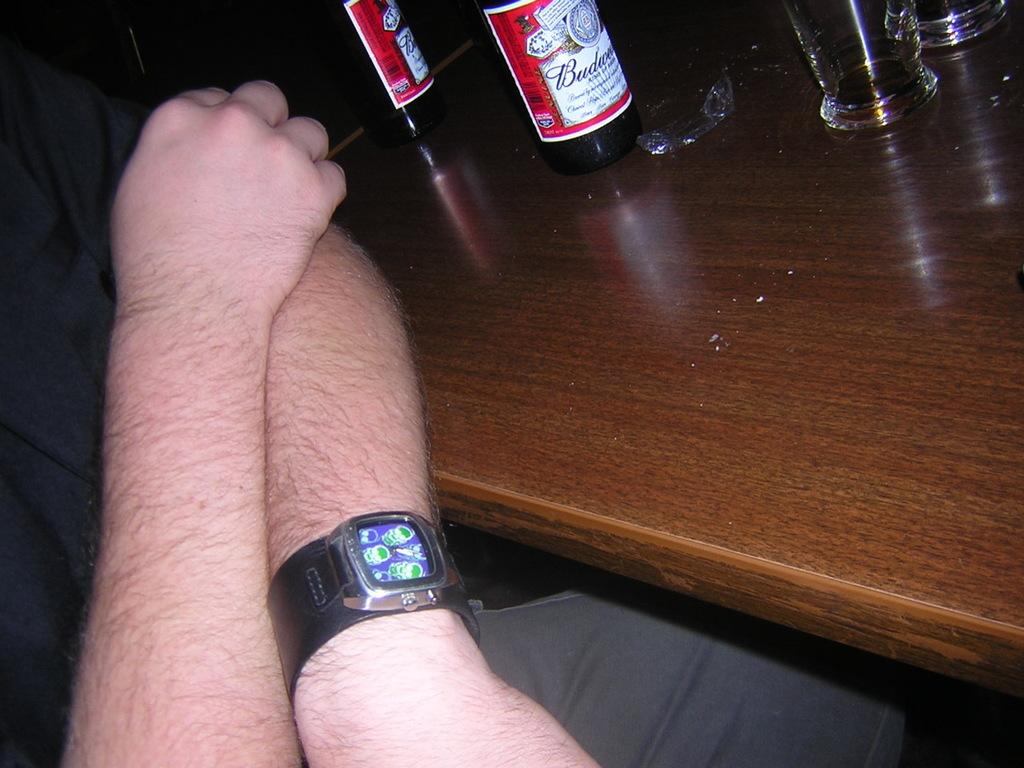Provide a one-sentence caption for the provided image. A person sitting next to a Budweiser bottle. 